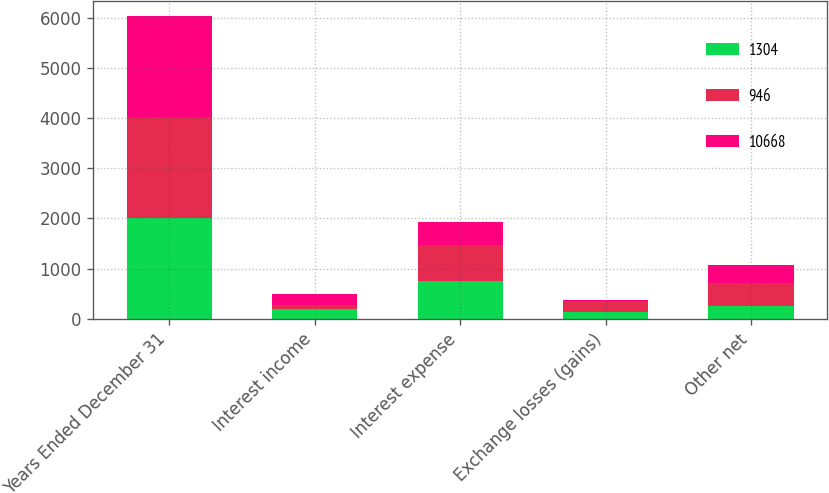Convert chart to OTSL. <chart><loc_0><loc_0><loc_500><loc_500><stacked_bar_chart><ecel><fcel>Years Ended December 31<fcel>Interest income<fcel>Interest expense<fcel>Exchange losses (gains)<fcel>Other net<nl><fcel>1304<fcel>2011<fcel>199<fcel>749<fcel>143<fcel>253<nl><fcel>946<fcel>2010<fcel>83<fcel>715<fcel>214<fcel>458<nl><fcel>10668<fcel>2009<fcel>210<fcel>460<fcel>12<fcel>355.5<nl></chart> 